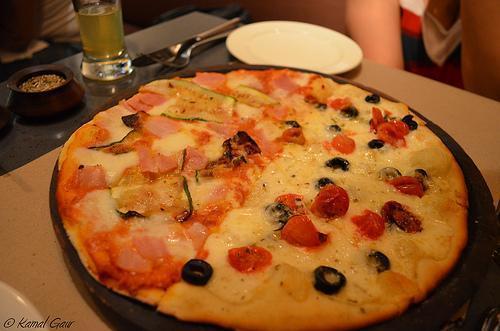How many whole pies?
Give a very brief answer. 1. 